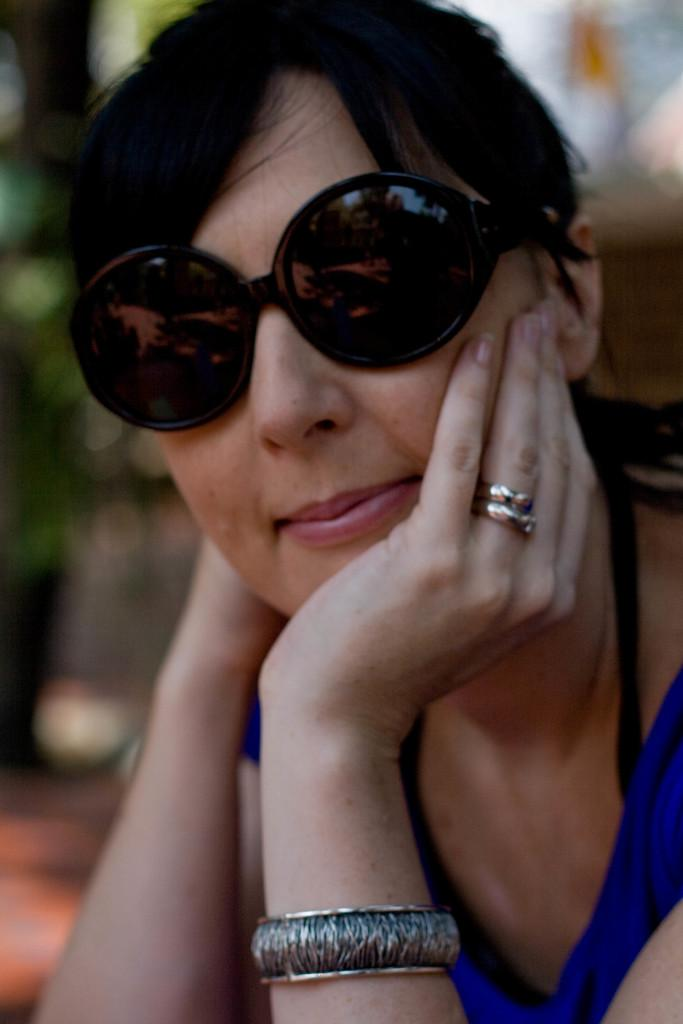Who is the main subject in the image? There is a woman in the image. Where is the woman located in the image? The woman is sitting in the center of the image. What is the woman's facial expression in the image? The woman is smiling in the image. What accessory is the woman wearing in the image? The woman is wearing sunglasses in the image. How many eggs can be seen in the woman's hand in the image? There are no eggs visible in the image; the woman is wearing sunglasses and smiling. Is there a yak present in the image? No, there is no yak present in the image. 